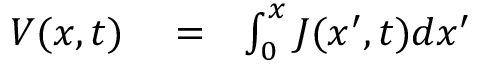Convert formula to latex. <formula><loc_0><loc_0><loc_500><loc_500>\begin{array} { r l r } { V ( x , t ) } & = } & { \int _ { 0 } ^ { x } J ( x ^ { \prime } , t ) d x ^ { \prime } } \end{array}</formula> 